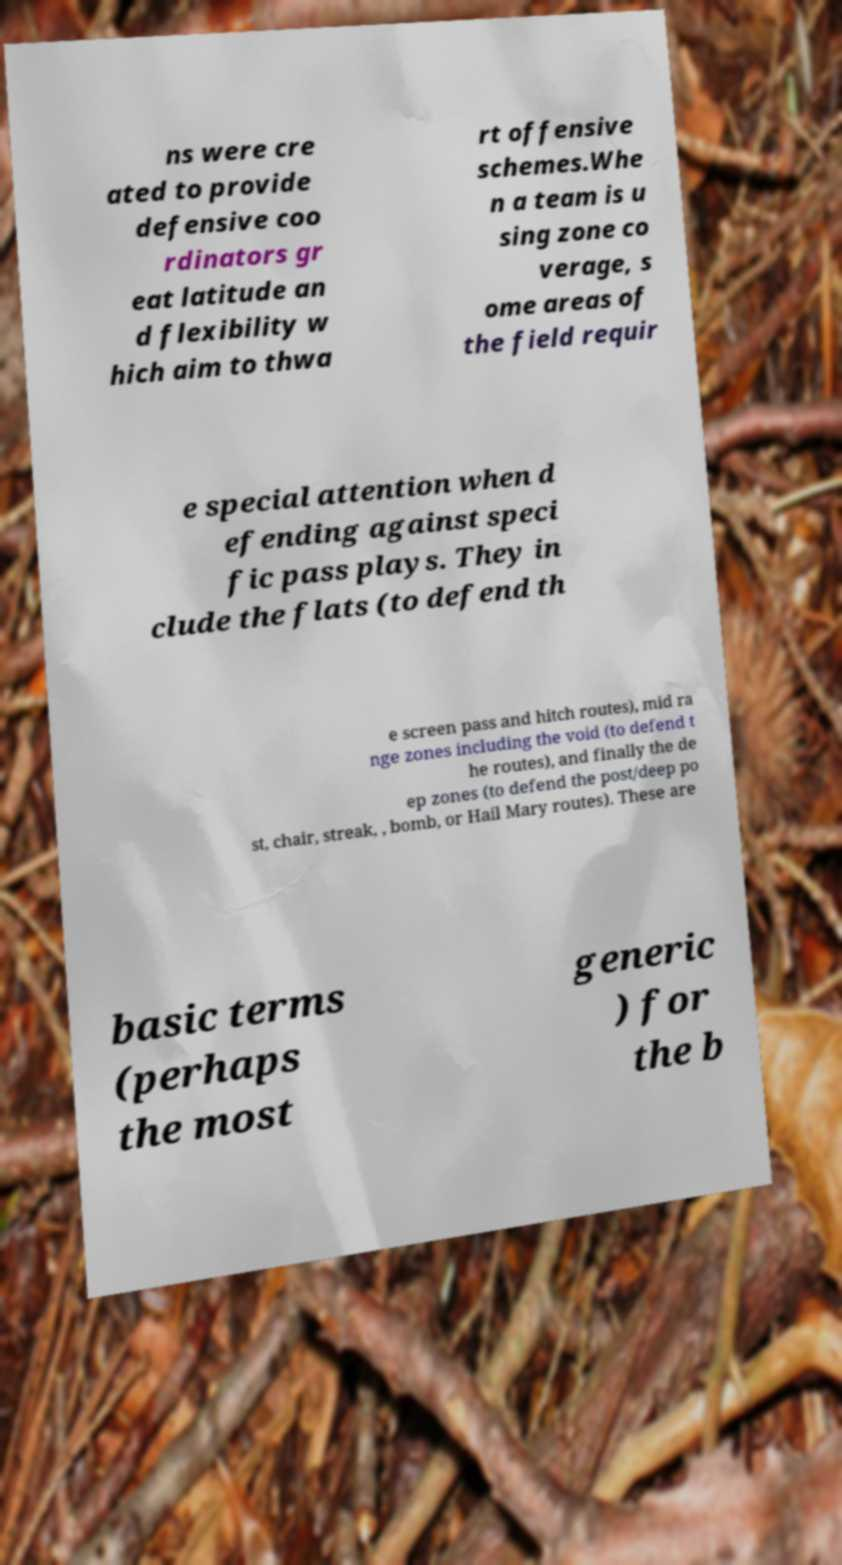For documentation purposes, I need the text within this image transcribed. Could you provide that? ns were cre ated to provide defensive coo rdinators gr eat latitude an d flexibility w hich aim to thwa rt offensive schemes.Whe n a team is u sing zone co verage, s ome areas of the field requir e special attention when d efending against speci fic pass plays. They in clude the flats (to defend th e screen pass and hitch routes), mid ra nge zones including the void (to defend t he routes), and finally the de ep zones (to defend the post/deep po st, chair, streak, , bomb, or Hail Mary routes). These are basic terms (perhaps the most generic ) for the b 